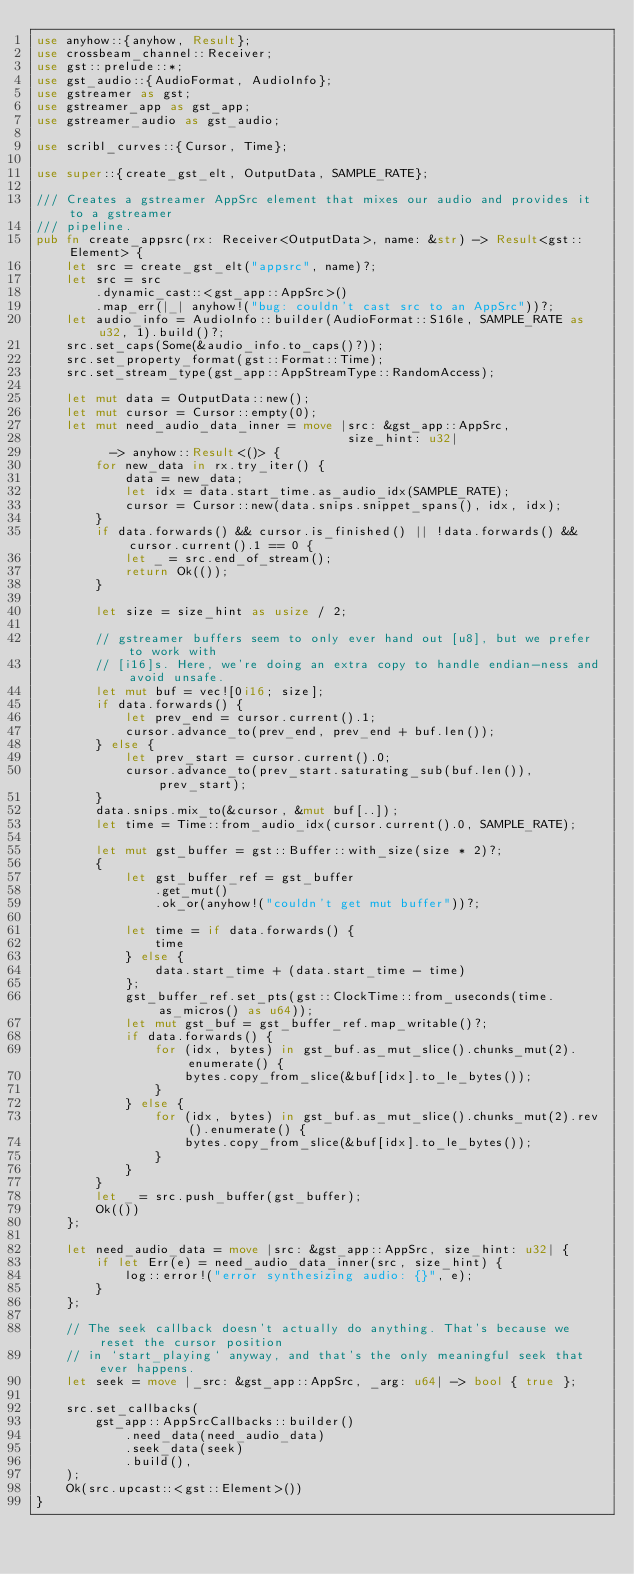Convert code to text. <code><loc_0><loc_0><loc_500><loc_500><_Rust_>use anyhow::{anyhow, Result};
use crossbeam_channel::Receiver;
use gst::prelude::*;
use gst_audio::{AudioFormat, AudioInfo};
use gstreamer as gst;
use gstreamer_app as gst_app;
use gstreamer_audio as gst_audio;

use scribl_curves::{Cursor, Time};

use super::{create_gst_elt, OutputData, SAMPLE_RATE};

/// Creates a gstreamer AppSrc element that mixes our audio and provides it to a gstreamer
/// pipeline.
pub fn create_appsrc(rx: Receiver<OutputData>, name: &str) -> Result<gst::Element> {
    let src = create_gst_elt("appsrc", name)?;
    let src = src
        .dynamic_cast::<gst_app::AppSrc>()
        .map_err(|_| anyhow!("bug: couldn't cast src to an AppSrc"))?;
    let audio_info = AudioInfo::builder(AudioFormat::S16le, SAMPLE_RATE as u32, 1).build()?;
    src.set_caps(Some(&audio_info.to_caps()?));
    src.set_property_format(gst::Format::Time);
    src.set_stream_type(gst_app::AppStreamType::RandomAccess);

    let mut data = OutputData::new();
    let mut cursor = Cursor::empty(0);
    let mut need_audio_data_inner = move |src: &gst_app::AppSrc,
                                          size_hint: u32|
          -> anyhow::Result<()> {
        for new_data in rx.try_iter() {
            data = new_data;
            let idx = data.start_time.as_audio_idx(SAMPLE_RATE);
            cursor = Cursor::new(data.snips.snippet_spans(), idx, idx);
        }
        if data.forwards() && cursor.is_finished() || !data.forwards() && cursor.current().1 == 0 {
            let _ = src.end_of_stream();
            return Ok(());
        }

        let size = size_hint as usize / 2;

        // gstreamer buffers seem to only ever hand out [u8], but we prefer to work with
        // [i16]s. Here, we're doing an extra copy to handle endian-ness and avoid unsafe.
        let mut buf = vec![0i16; size];
        if data.forwards() {
            let prev_end = cursor.current().1;
            cursor.advance_to(prev_end, prev_end + buf.len());
        } else {
            let prev_start = cursor.current().0;
            cursor.advance_to(prev_start.saturating_sub(buf.len()), prev_start);
        }
        data.snips.mix_to(&cursor, &mut buf[..]);
        let time = Time::from_audio_idx(cursor.current().0, SAMPLE_RATE);

        let mut gst_buffer = gst::Buffer::with_size(size * 2)?;
        {
            let gst_buffer_ref = gst_buffer
                .get_mut()
                .ok_or(anyhow!("couldn't get mut buffer"))?;

            let time = if data.forwards() {
                time
            } else {
                data.start_time + (data.start_time - time)
            };
            gst_buffer_ref.set_pts(gst::ClockTime::from_useconds(time.as_micros() as u64));
            let mut gst_buf = gst_buffer_ref.map_writable()?;
            if data.forwards() {
                for (idx, bytes) in gst_buf.as_mut_slice().chunks_mut(2).enumerate() {
                    bytes.copy_from_slice(&buf[idx].to_le_bytes());
                }
            } else {
                for (idx, bytes) in gst_buf.as_mut_slice().chunks_mut(2).rev().enumerate() {
                    bytes.copy_from_slice(&buf[idx].to_le_bytes());
                }
            }
        }
        let _ = src.push_buffer(gst_buffer);
        Ok(())
    };

    let need_audio_data = move |src: &gst_app::AppSrc, size_hint: u32| {
        if let Err(e) = need_audio_data_inner(src, size_hint) {
            log::error!("error synthesizing audio: {}", e);
        }
    };

    // The seek callback doesn't actually do anything. That's because we reset the cursor position
    // in `start_playing` anyway, and that's the only meaningful seek that ever happens.
    let seek = move |_src: &gst_app::AppSrc, _arg: u64| -> bool { true };

    src.set_callbacks(
        gst_app::AppSrcCallbacks::builder()
            .need_data(need_audio_data)
            .seek_data(seek)
            .build(),
    );
    Ok(src.upcast::<gst::Element>())
}
</code> 